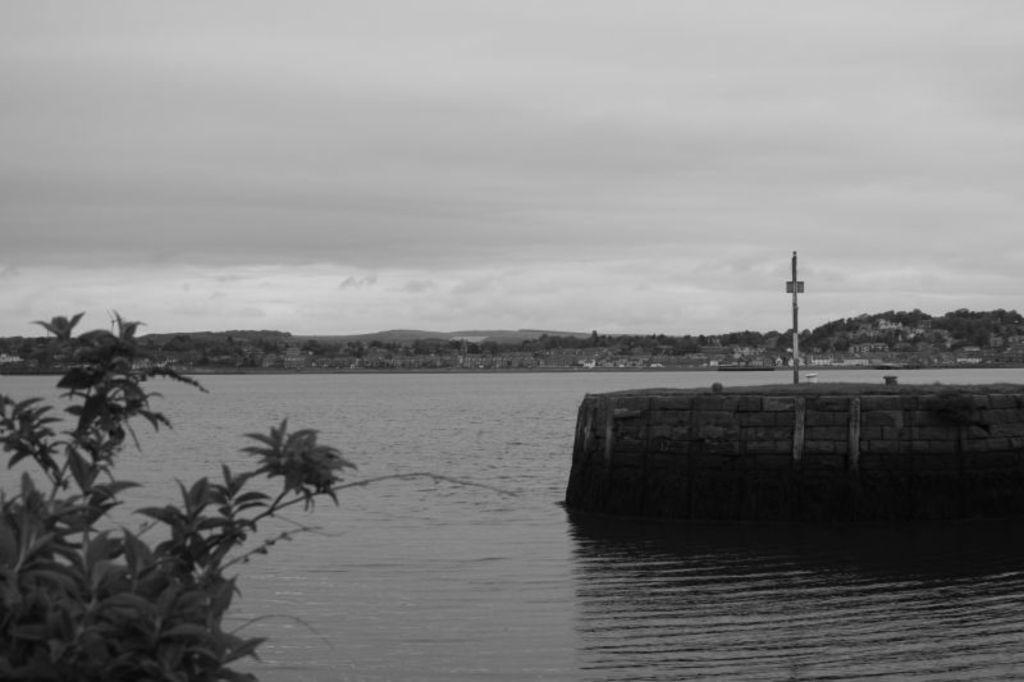In one or two sentences, can you explain what this image depicts? This is the picture of a lake. In this image there are mountains, trees and buildings. On the right side of the image there is a pole on the wall. On the left side of the image there is a tree. At the top there is sky. At the bottom there is water. 